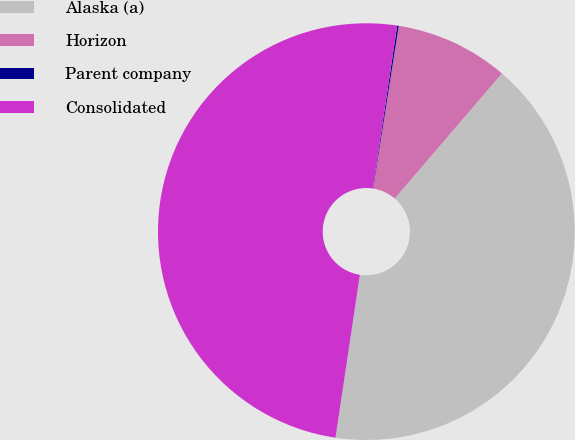Convert chart. <chart><loc_0><loc_0><loc_500><loc_500><pie_chart><fcel>Alaska (a)<fcel>Horizon<fcel>Parent company<fcel>Consolidated<nl><fcel>41.09%<fcel>8.79%<fcel>0.12%<fcel>50.0%<nl></chart> 